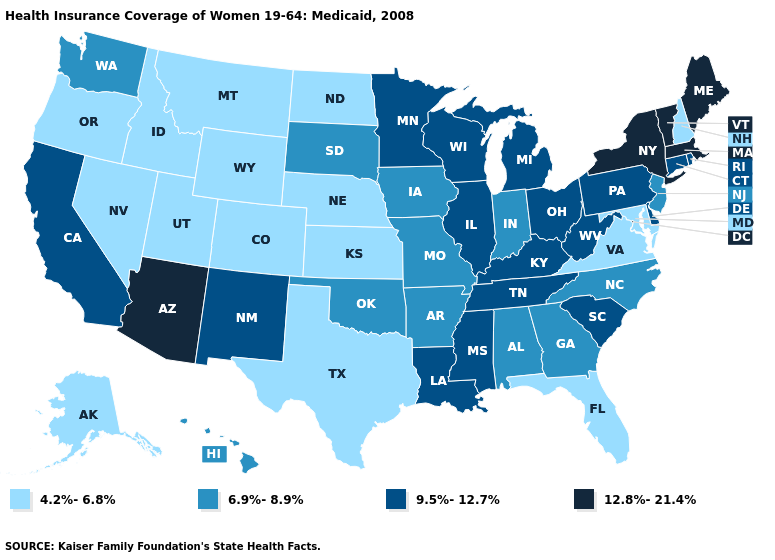Which states have the lowest value in the Northeast?
Concise answer only. New Hampshire. Does the first symbol in the legend represent the smallest category?
Quick response, please. Yes. Among the states that border Colorado , which have the lowest value?
Quick response, please. Kansas, Nebraska, Utah, Wyoming. What is the highest value in the South ?
Quick response, please. 9.5%-12.7%. What is the highest value in the USA?
Write a very short answer. 12.8%-21.4%. Name the states that have a value in the range 9.5%-12.7%?
Concise answer only. California, Connecticut, Delaware, Illinois, Kentucky, Louisiana, Michigan, Minnesota, Mississippi, New Mexico, Ohio, Pennsylvania, Rhode Island, South Carolina, Tennessee, West Virginia, Wisconsin. Which states have the lowest value in the West?
Give a very brief answer. Alaska, Colorado, Idaho, Montana, Nevada, Oregon, Utah, Wyoming. What is the value of Montana?
Be succinct. 4.2%-6.8%. Name the states that have a value in the range 6.9%-8.9%?
Keep it brief. Alabama, Arkansas, Georgia, Hawaii, Indiana, Iowa, Missouri, New Jersey, North Carolina, Oklahoma, South Dakota, Washington. Is the legend a continuous bar?
Write a very short answer. No. Name the states that have a value in the range 4.2%-6.8%?
Write a very short answer. Alaska, Colorado, Florida, Idaho, Kansas, Maryland, Montana, Nebraska, Nevada, New Hampshire, North Dakota, Oregon, Texas, Utah, Virginia, Wyoming. Which states have the lowest value in the South?
Quick response, please. Florida, Maryland, Texas, Virginia. Name the states that have a value in the range 6.9%-8.9%?
Give a very brief answer. Alabama, Arkansas, Georgia, Hawaii, Indiana, Iowa, Missouri, New Jersey, North Carolina, Oklahoma, South Dakota, Washington. Does Arkansas have the same value as Montana?
Answer briefly. No. What is the lowest value in the West?
Give a very brief answer. 4.2%-6.8%. 